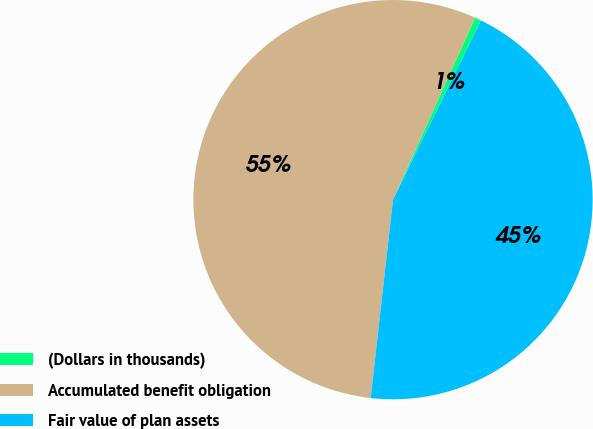Convert chart. <chart><loc_0><loc_0><loc_500><loc_500><pie_chart><fcel>(Dollars in thousands)<fcel>Accumulated benefit obligation<fcel>Fair value of plan assets<nl><fcel>0.52%<fcel>54.96%<fcel>44.52%<nl></chart> 